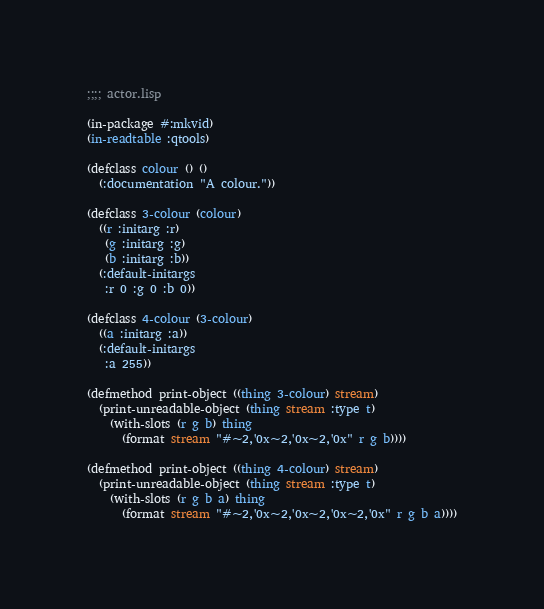<code> <loc_0><loc_0><loc_500><loc_500><_Lisp_>;;;; actor.lisp

(in-package #:mkvid)
(in-readtable :qtools)

(defclass colour () ()
  (:documentation "A colour."))

(defclass 3-colour (colour)
  ((r :initarg :r)
   (g :initarg :g)
   (b :initarg :b))
  (:default-initargs
   :r 0 :g 0 :b 0))

(defclass 4-colour (3-colour)
  ((a :initarg :a))
  (:default-initargs
   :a 255))

(defmethod print-object ((thing 3-colour) stream)
  (print-unreadable-object (thing stream :type t)
    (with-slots (r g b) thing
      (format stream "#~2,'0x~2,'0x~2,'0x" r g b))))

(defmethod print-object ((thing 4-colour) stream)
  (print-unreadable-object (thing stream :type t)
    (with-slots (r g b a) thing
      (format stream "#~2,'0x~2,'0x~2,'0x~2,'0x" r g b a))))
</code> 